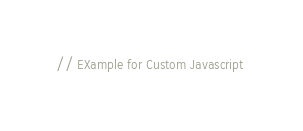Convert code to text. <code><loc_0><loc_0><loc_500><loc_500><_JavaScript_>// EXample for Custom Javascript </code> 